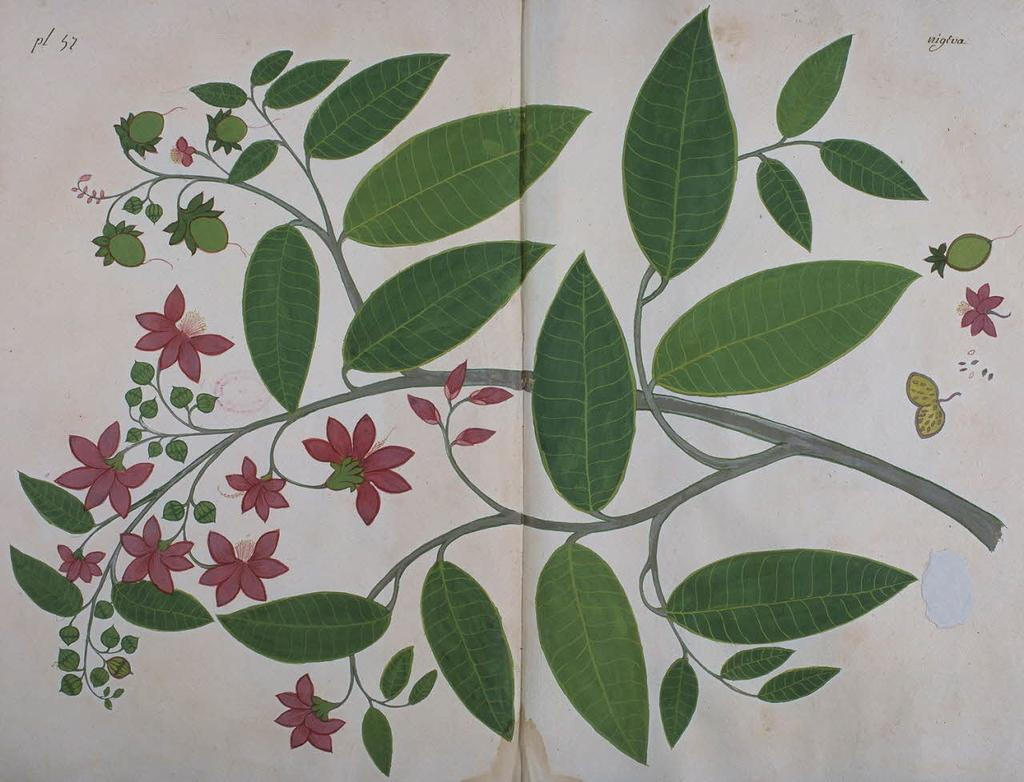What is depicted on the white surface in the image? There are paintings on a white surface in the image. What elements can be found within the paintings? Leaves, stems, branches, flowers, and flower buds are present in the paintings. What is visible at the top of the image? There is text visible at the top of the image. What type of drug is being advertised in the image? There is no drug being advertised in the image; it features paintings with various elements. How does the image depict the level of pollution in the area? The image does not depict the level of pollution; it focuses on paintings with leaves, stems, branches, flowers, and flower buds. 